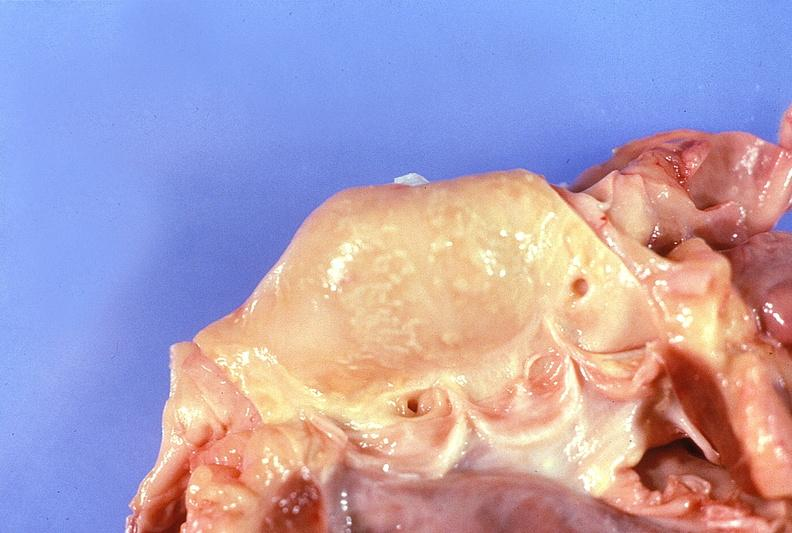where is this?
Answer the question using a single word or phrase. Heart 